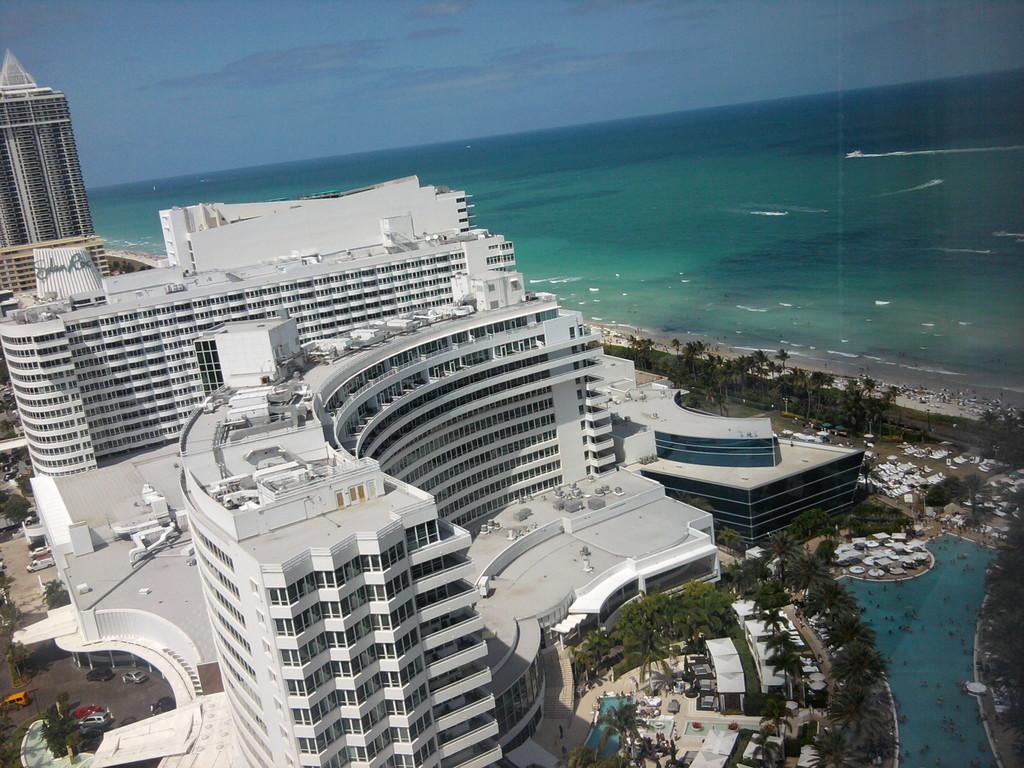How would you summarize this image in a sentence or two? In this image I can see buildings in white and cream color, few vehicles on the road, trees in green color, water in blue color. Background the sky is in blue color. 